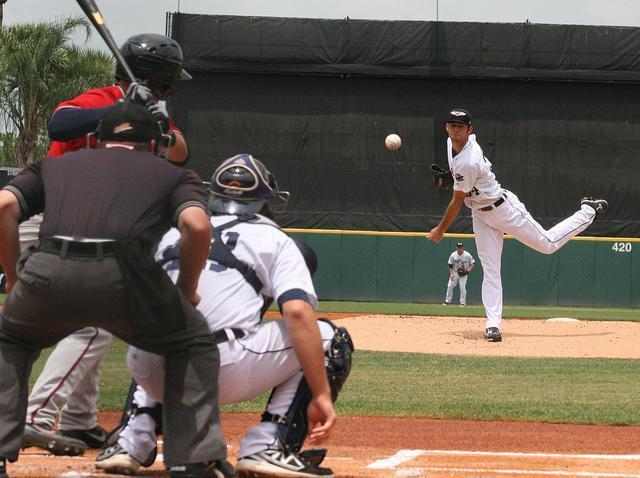How many people are in the photo?
Give a very brief answer. 4. 